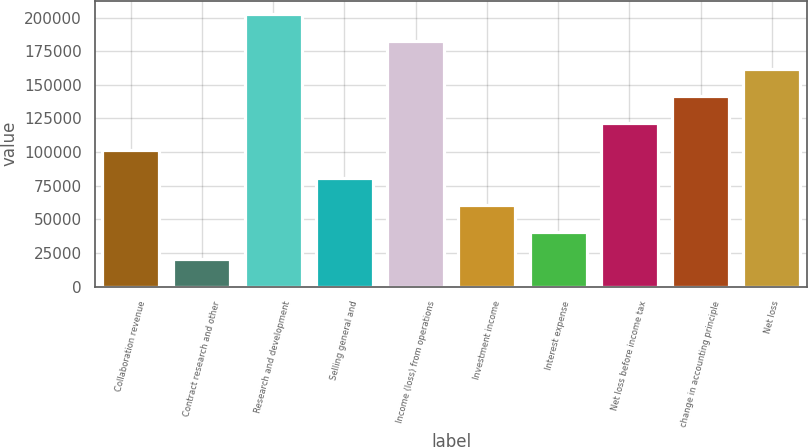Convert chart. <chart><loc_0><loc_0><loc_500><loc_500><bar_chart><fcel>Collaboration revenue<fcel>Contract research and other<fcel>Research and development<fcel>Selling general and<fcel>Income (loss) from operations<fcel>Investment income<fcel>Interest expense<fcel>Net loss before income tax<fcel>change in accounting principle<fcel>Net loss<nl><fcel>101235<fcel>20248.2<fcel>202468<fcel>80988.2<fcel>182221<fcel>60741.5<fcel>40494.9<fcel>121481<fcel>141728<fcel>161975<nl></chart> 